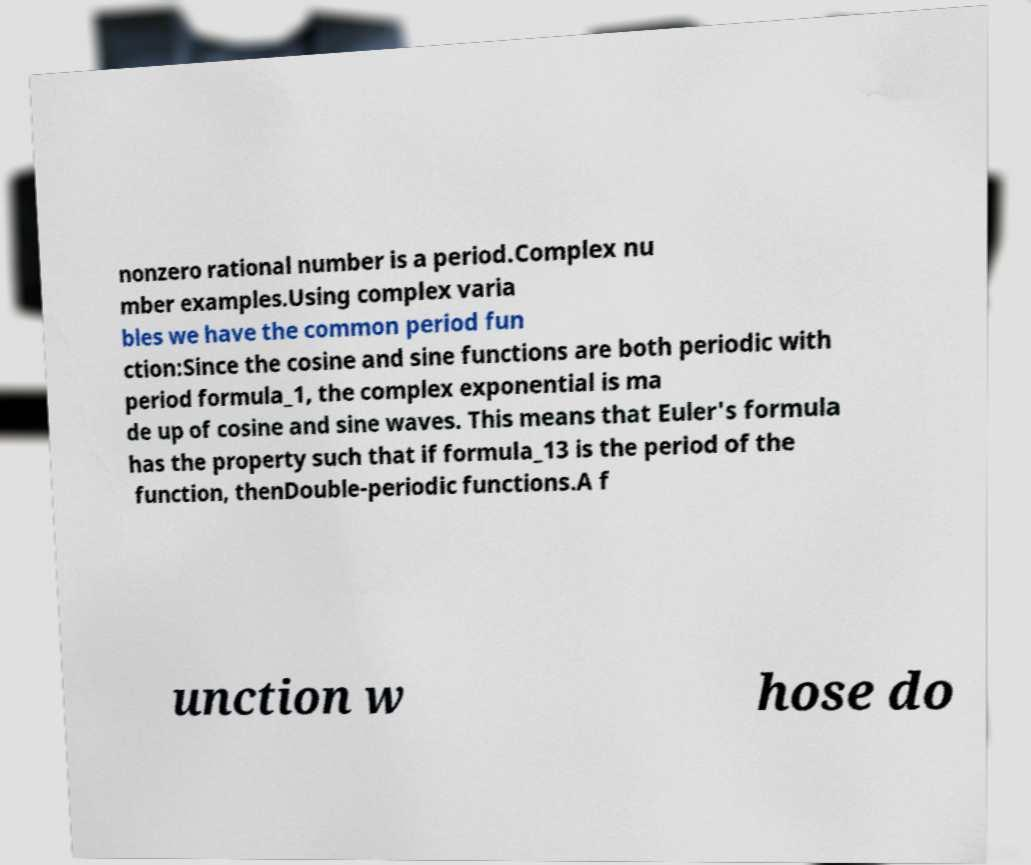I need the written content from this picture converted into text. Can you do that? nonzero rational number is a period.Complex nu mber examples.Using complex varia bles we have the common period fun ction:Since the cosine and sine functions are both periodic with period formula_1, the complex exponential is ma de up of cosine and sine waves. This means that Euler's formula has the property such that if formula_13 is the period of the function, thenDouble-periodic functions.A f unction w hose do 